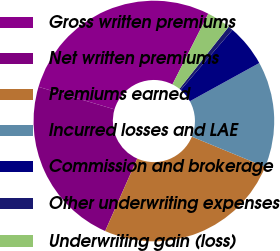Convert chart to OTSL. <chart><loc_0><loc_0><loc_500><loc_500><pie_chart><fcel>Gross written premiums<fcel>Net written premiums<fcel>Premiums earned<fcel>Incurred losses and LAE<fcel>Commission and brokerage<fcel>Other underwriting expenses<fcel>Underwriting gain (loss)<nl><fcel>27.88%<fcel>22.95%<fcel>25.41%<fcel>14.23%<fcel>5.67%<fcel>0.65%<fcel>3.2%<nl></chart> 